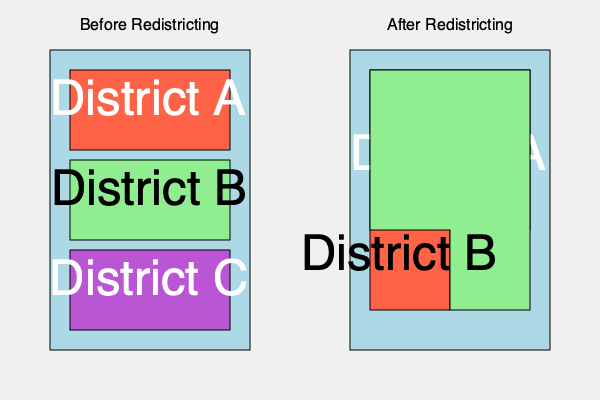Based on the before-and-after redistricting maps of Wisconsin shown above, what is the most significant change in the state's congressional representation, and how might this impact the political landscape? To analyze the impact of redistricting on Wisconsin's congressional representation, we need to examine the changes in the district maps:

1. Before redistricting:
   - There were three districts: A, B, and C.
   - The districts were roughly equal in size and shape.

2. After redistricting:
   - There are now only two districts: A and B.
   - The shapes of the districts have changed significantly.
   - District A now covers a larger area, encompassing most of the former District C.
   - District B has been reshaped and reduced in size.

3. Impact on representation:
   - The most significant change is the reduction from three congressional districts to two.
   - This implies that Wisconsin has lost one congressional seat.

4. Political implications:
   - The loss of a congressional seat means less representation for Wisconsin in the U.S. House of Representatives.
   - The new district boundaries may alter the political demographics of each district.
   - District A's expansion could potentially dilute the voting power of certain communities.
   - The reshaping of District B might concentrate certain voter groups, potentially affecting election outcomes.

5. Factors to consider:
   - Population shifts: The redistricting likely reflects changes in population distribution across the state.
   - Partisan gerrymandering: The new boundaries could be drawn to favor a particular political party.
   - Voting Rights Act compliance: The new districts must still adhere to federal voting rights laws.

6. Potential consequences:
   - Changed political dynamics in future elections.
   - Altered representation of urban vs. rural interests.
   - Possible legal challenges to the new district map.

The most significant change is the loss of one congressional district, which will have far-reaching effects on Wisconsin's political representation and power at the federal level.
Answer: Loss of one congressional seat, potentially altering political balance and reducing federal representation. 